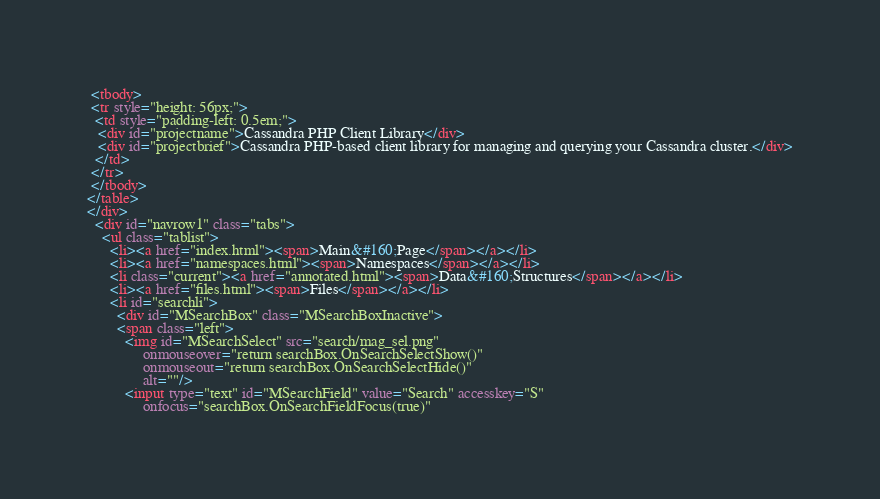Convert code to text. <code><loc_0><loc_0><loc_500><loc_500><_HTML_> <tbody>
 <tr style="height: 56px;">
  <td style="padding-left: 0.5em;">
   <div id="projectname">Cassandra PHP Client Library</div>
   <div id="projectbrief">Cassandra PHP-based client library for managing and querying your Cassandra cluster.</div>
  </td>
 </tr>
 </tbody>
</table>
</div>
  <div id="navrow1" class="tabs">
    <ul class="tablist">
      <li><a href="index.html"><span>Main&#160;Page</span></a></li>
      <li><a href="namespaces.html"><span>Namespaces</span></a></li>
      <li class="current"><a href="annotated.html"><span>Data&#160;Structures</span></a></li>
      <li><a href="files.html"><span>Files</span></a></li>
      <li id="searchli">
        <div id="MSearchBox" class="MSearchBoxInactive">
        <span class="left">
          <img id="MSearchSelect" src="search/mag_sel.png"
               onmouseover="return searchBox.OnSearchSelectShow()"
               onmouseout="return searchBox.OnSearchSelectHide()"
               alt=""/>
          <input type="text" id="MSearchField" value="Search" accesskey="S"
               onfocus="searchBox.OnSearchFieldFocus(true)" </code> 